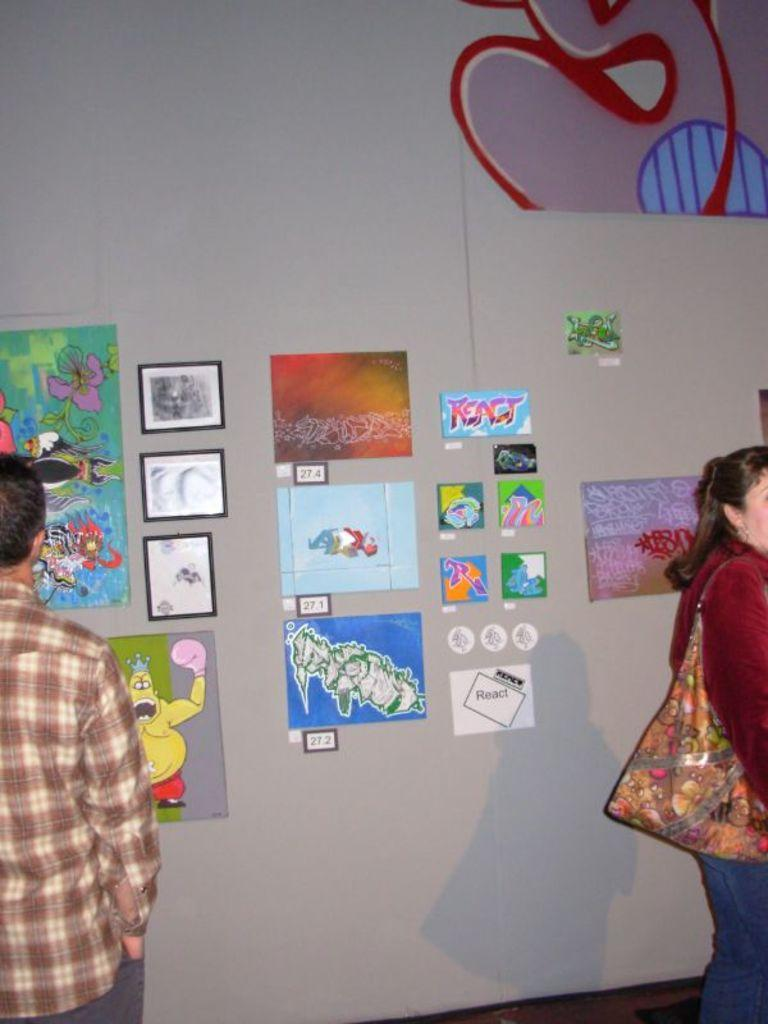What can be seen on the wall in the image? There is a wall with posters and photo frames in the image. How many people are in the image? There are two persons in the image. What is one of the persons holding or carrying? One of the persons is carrying a bag. What type of trousers is the person wearing in the image? There is no information about the person's trousers in the image, so we cannot determine the type of trousers they are wearing. --- Facts: 1. There is a car in the image. 2. The car is parked on the street. 3. There are trees on both sides of the street. 4. The sky is visible in the image. Absurd Topics: parade, dance, ocean Conversation: What is the main subject of the image? The main subject of the image is a car. Where is the car located in the image? The car is parked on the street. What can be seen on both sides of the street? There are trees on both sides of the street. What is visible in the background of the image? The sky is visible in the image. Reasoning: Let's think step by step in order to produce the conversation. We start by identifying the main subject in the image, which is the car. Then, we describe the car's location, noting that it is parked on the street. Next, we expand the conversation to include the surrounding environment, mentioning the trees on both sides of the street. Finally, we describe the background of the image, which is the sky. Absurd Question/Answer: Can you see the ocean in the image? No, the ocean is not visible in the image; only the car, street, trees, and sky can be seen. --- Facts: 1. There is a person sitting on a bench in the image. 2. The person is reading a book. 3. There is a tree behind the bench. 4. The ground is visible in the image. Absurd Topics: dance, concert, chessboard, elephant Conversation: What is the person in the image doing? The person is sitting on a bench and reading a book. What can be seen behind the bench in the image? There is a tree behind the bench. What is visible on the ground in the image? The ground is visible in the image. Reasoning: Let's think step by step in order to produce the conversation. We start by identifying the main subject in the image, which is the person sitting on the bench. Then, we describe what the person is doing, noting that they are reading a book. Next, we expand the conversation to include the surrounding environment, mentioning the tree behind the bench. Finally, we describe the ground in the image. Absurd Question/Answer: 